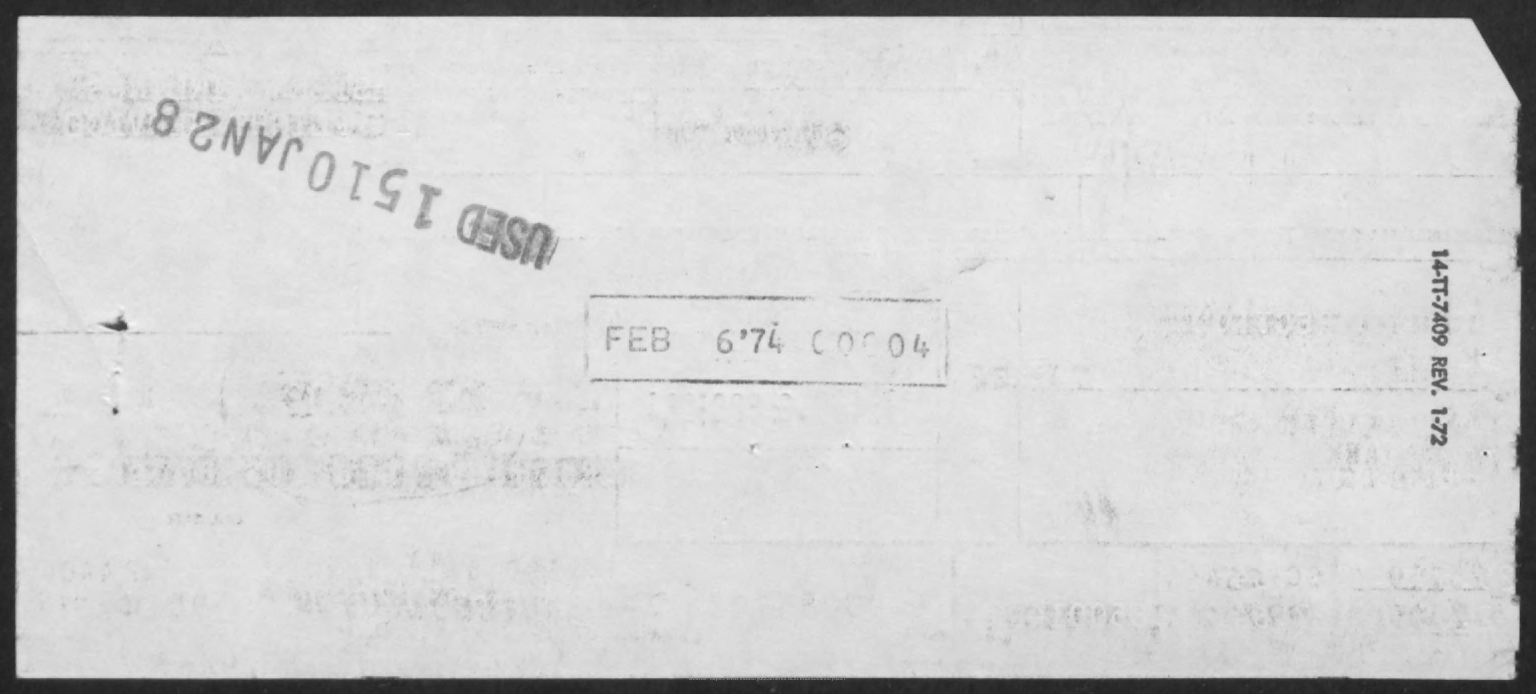Which month is seen in the rectangle shaped seal?
Your answer should be very brief. FEB. 